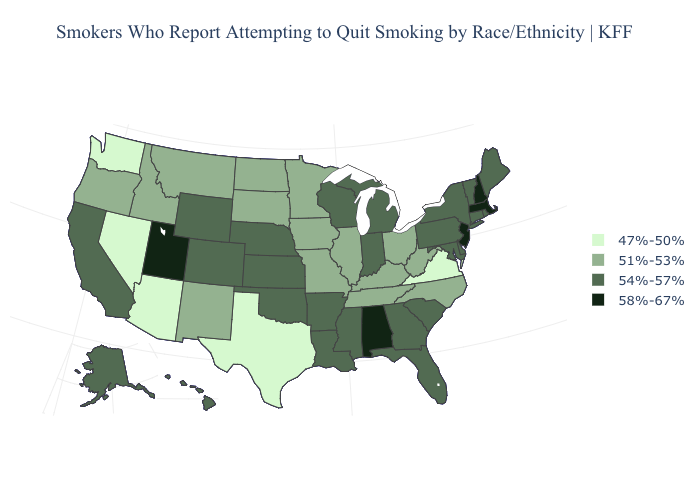What is the value of Ohio?
Give a very brief answer. 51%-53%. How many symbols are there in the legend?
Quick response, please. 4. What is the highest value in states that border Wyoming?
Be succinct. 58%-67%. Does Indiana have the highest value in the MidWest?
Keep it brief. Yes. What is the lowest value in the MidWest?
Give a very brief answer. 51%-53%. Name the states that have a value in the range 47%-50%?
Concise answer only. Arizona, Nevada, Texas, Virginia, Washington. Which states have the lowest value in the USA?
Keep it brief. Arizona, Nevada, Texas, Virginia, Washington. What is the value of Nevada?
Answer briefly. 47%-50%. What is the lowest value in the Northeast?
Quick response, please. 54%-57%. Is the legend a continuous bar?
Quick response, please. No. What is the lowest value in the Northeast?
Keep it brief. 54%-57%. What is the lowest value in states that border Illinois?
Answer briefly. 51%-53%. Name the states that have a value in the range 47%-50%?
Write a very short answer. Arizona, Nevada, Texas, Virginia, Washington. What is the value of North Dakota?
Be succinct. 51%-53%. Name the states that have a value in the range 51%-53%?
Concise answer only. Idaho, Illinois, Iowa, Kentucky, Minnesota, Missouri, Montana, New Mexico, North Carolina, North Dakota, Ohio, Oregon, South Dakota, Tennessee, West Virginia. 